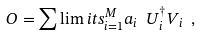Convert formula to latex. <formula><loc_0><loc_0><loc_500><loc_500>O = \sum \lim i t s _ { i = 1 } ^ { M } a _ { i } \ U ^ { \dagger } _ { i } V _ { i } \ ,</formula> 